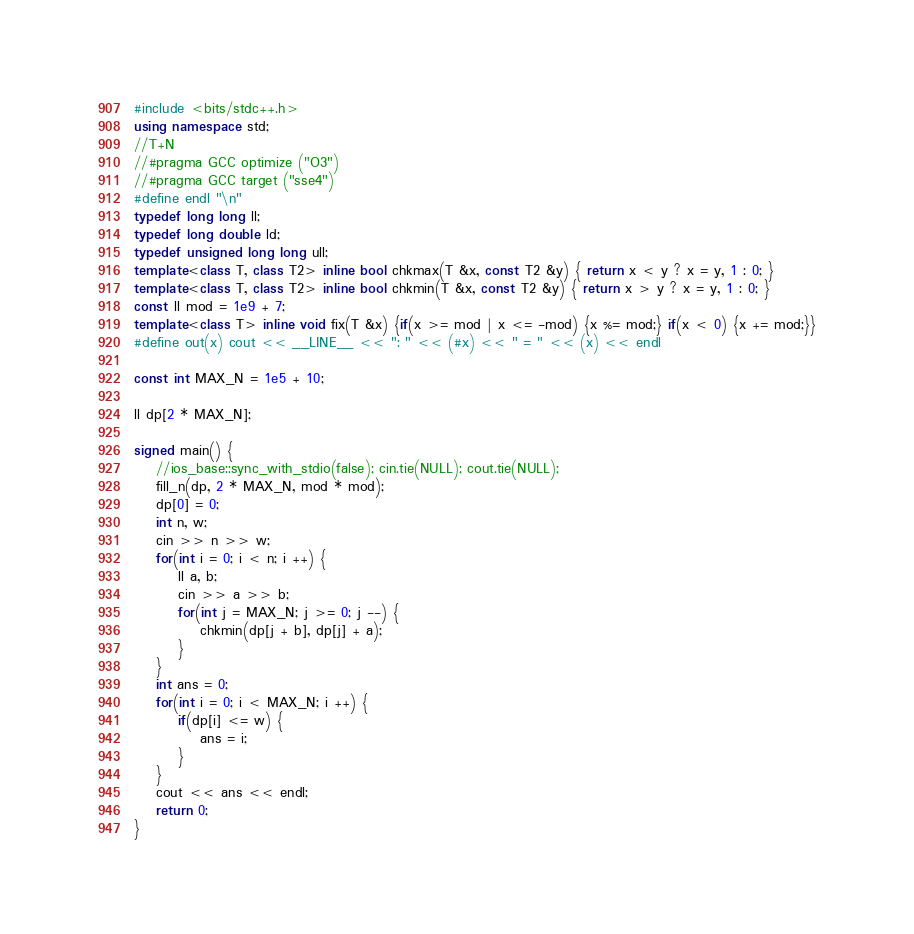<code> <loc_0><loc_0><loc_500><loc_500><_C++_>#include <bits/stdc++.h>
using namespace std;
//T+N
//#pragma GCC optimize ("O3")
//#pragma GCC target ("sse4")
#define endl "\n"
typedef long long ll;
typedef long double ld;
typedef unsigned long long ull;
template<class T, class T2> inline bool chkmax(T &x, const T2 &y) { return x < y ? x = y, 1 : 0; }
template<class T, class T2> inline bool chkmin(T &x, const T2 &y) { return x > y ? x = y, 1 : 0; }
const ll mod = 1e9 + 7;
template<class T> inline void fix(T &x) {if(x >= mod | x <= -mod) {x %= mod;} if(x < 0) {x += mod;}}
#define out(x) cout << __LINE__ << ": " << (#x) << " = " << (x) << endl

const int MAX_N = 1e5 + 10;

ll dp[2 * MAX_N];

signed main() {
    //ios_base::sync_with_stdio(false); cin.tie(NULL); cout.tie(NULL);
    fill_n(dp, 2 * MAX_N, mod * mod);
    dp[0] = 0;
    int n, w;
    cin >> n >> w;
    for(int i = 0; i < n; i ++) {
        ll a, b;
        cin >> a >> b;
        for(int j = MAX_N; j >= 0; j --) {
            chkmin(dp[j + b], dp[j] + a);
        }
    }
    int ans = 0;
    for(int i = 0; i < MAX_N; i ++) {
        if(dp[i] <= w) {
            ans = i;
        }
    }
    cout << ans << endl;
    return 0;
}

</code> 